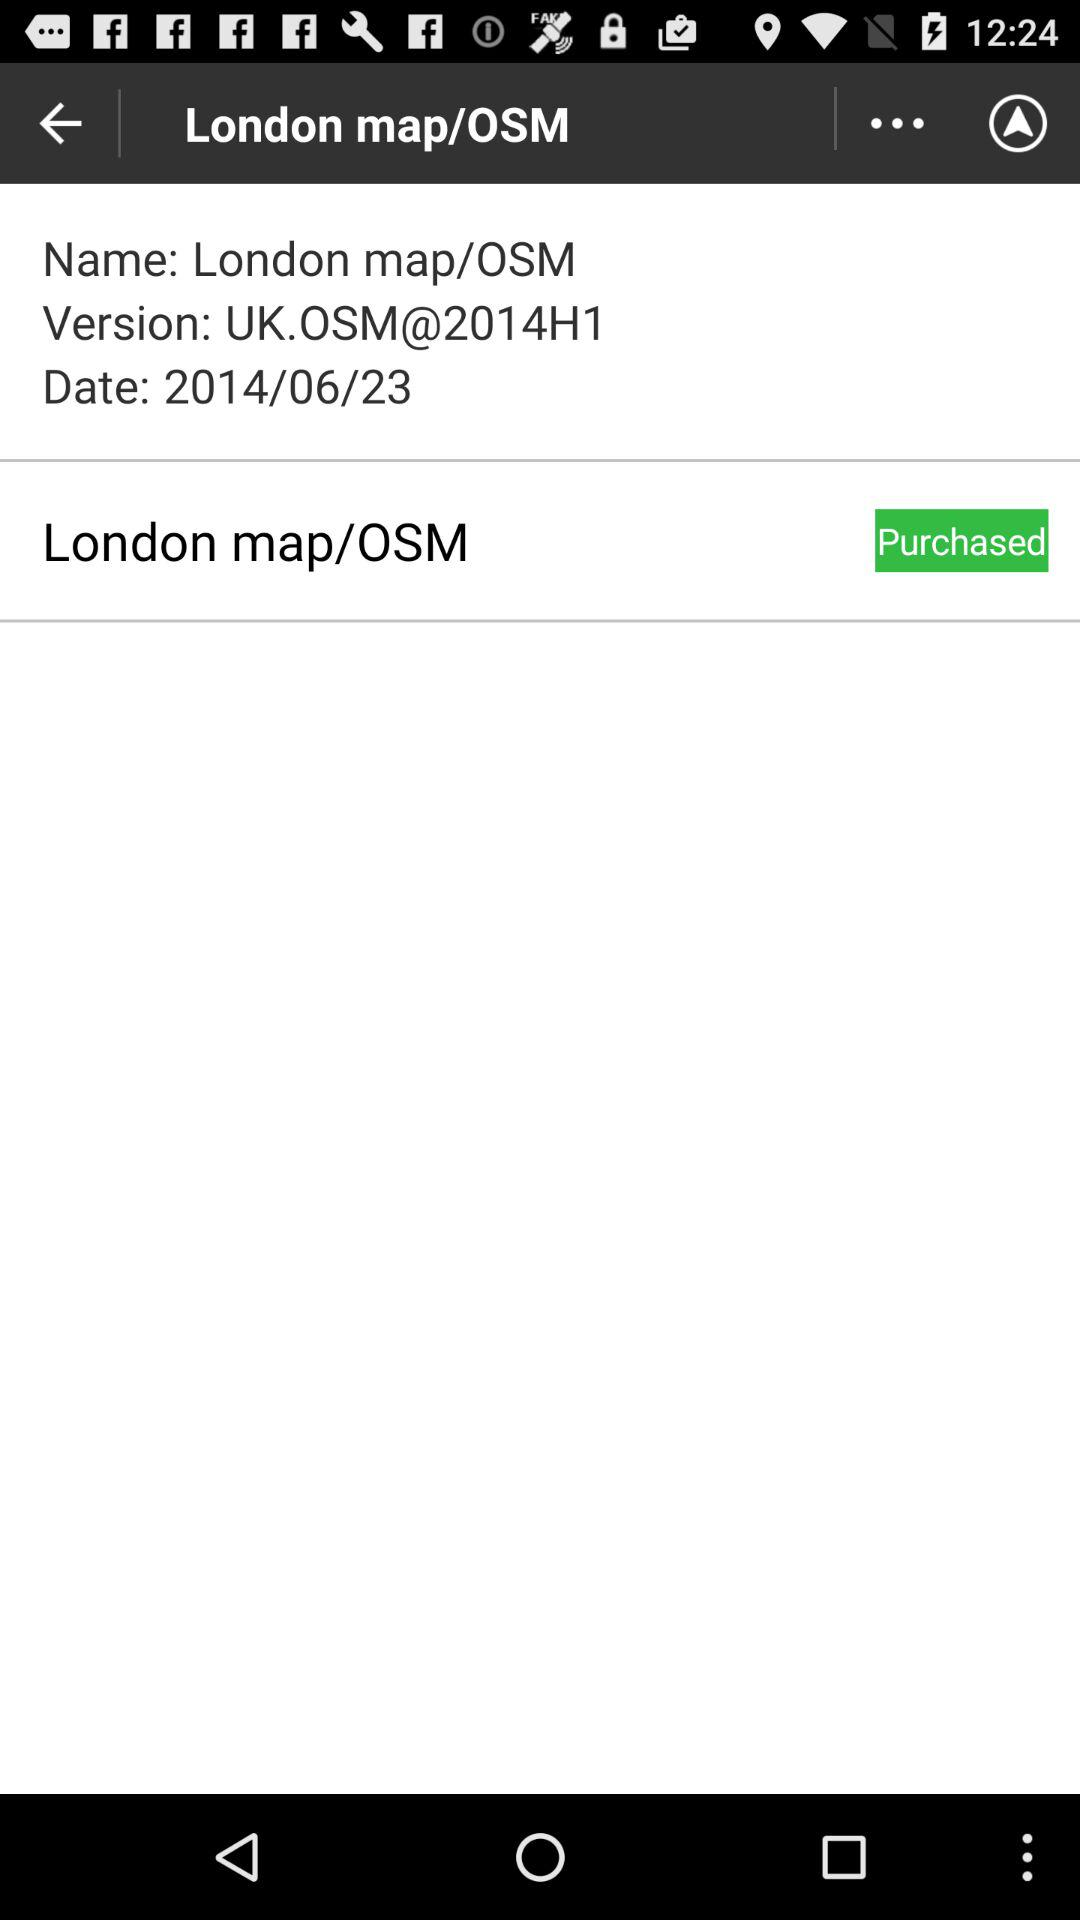What is the name of the version? The version name is "UK.OSM@2014H1". 